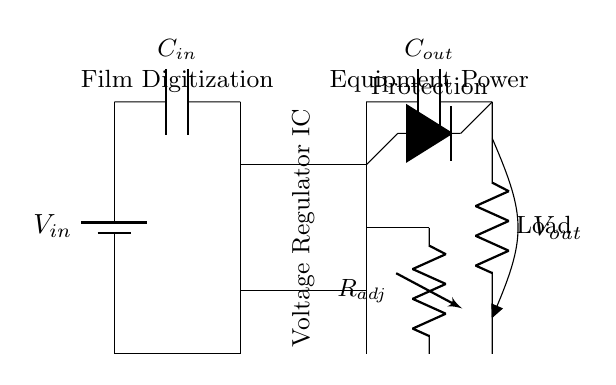What is the function of the voltage regulator IC? The voltage regulator IC is responsible for maintaining a stable output voltage despite variations in input voltage or load conditions. It ensures that delicate film digitization equipment receives the correct voltage level for optimal performance.
Answer: Voltage regulation What is the value of the input capacitor labeled as C_in? The circuit diagram does not specify the capacitance value of C_in; it only shows the component label. Therefore, the answer is indeterminate based on the provided information.
Answer: Not specified How is the output voltage obtained in this circuit? The output voltage is obtained by passing the input voltage through the voltage regulator IC, which adjusts the voltage level down to the desired output for the load. The wiring shows that the output is taken after the regulator IC.
Answer: Via the voltage regulator IC What is the role of the adjustable resistor R_adj? The adjustable resistor R_adj is used to fine-tune the output voltage level. By changing its resistance, you can adjust the voltage that the voltage regulator provides to the load, allowing for custom voltage settings needed for specific film digitization equipment.
Answer: Voltage adjustment What component provides protection to the voltage regulator IC? The protection diode connected in parallel with the load serves to protect the voltage regulator IC from reverse voltage conditions that could damage it, effectively acting as a safeguard.
Answer: Protection diode What is the purpose of the output capacitor labeled C_out? The output capacitor C_out is used to smooth out the regulated output voltage, filtering out voltage spikes and ensuring a stable power supply to the delicate film digitization equipment.
Answer: Smoothing/filtering Why is grounding essential in this circuit? Grounding provides a reference point for the circuit, ensuring that all components operate at a defined potential. It also helps to complete the electrical circuit, allowing current to return and preventing voltage fluctuations that could affect performance.
Answer: Current return/reference 